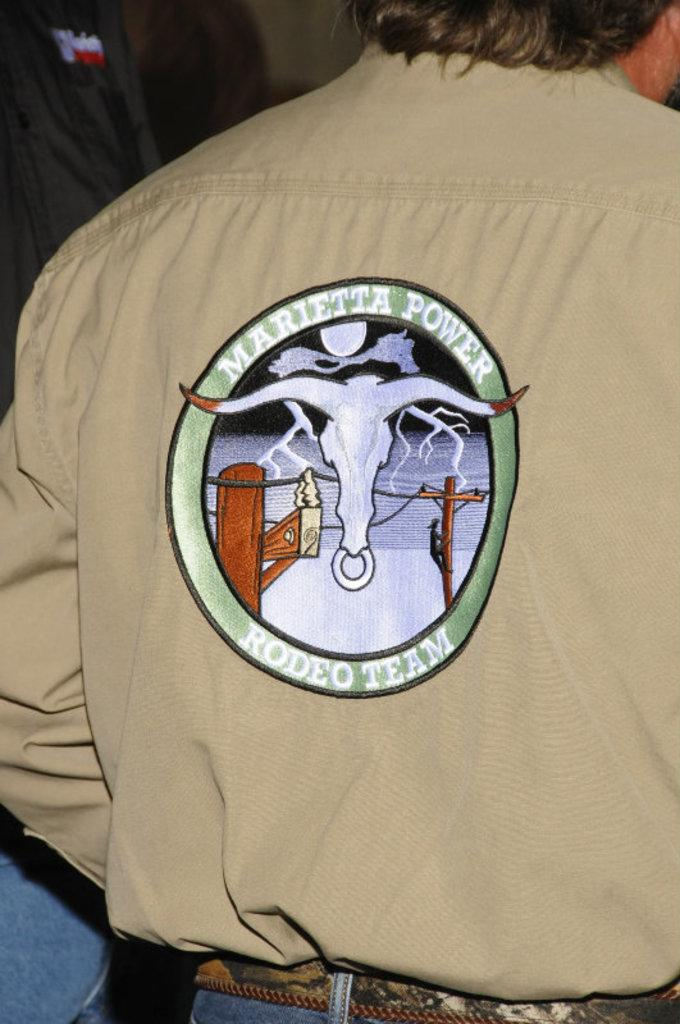<image>
Share a concise interpretation of the image provided. A person wears a tan shirt with "Marietta Power" on the back. 